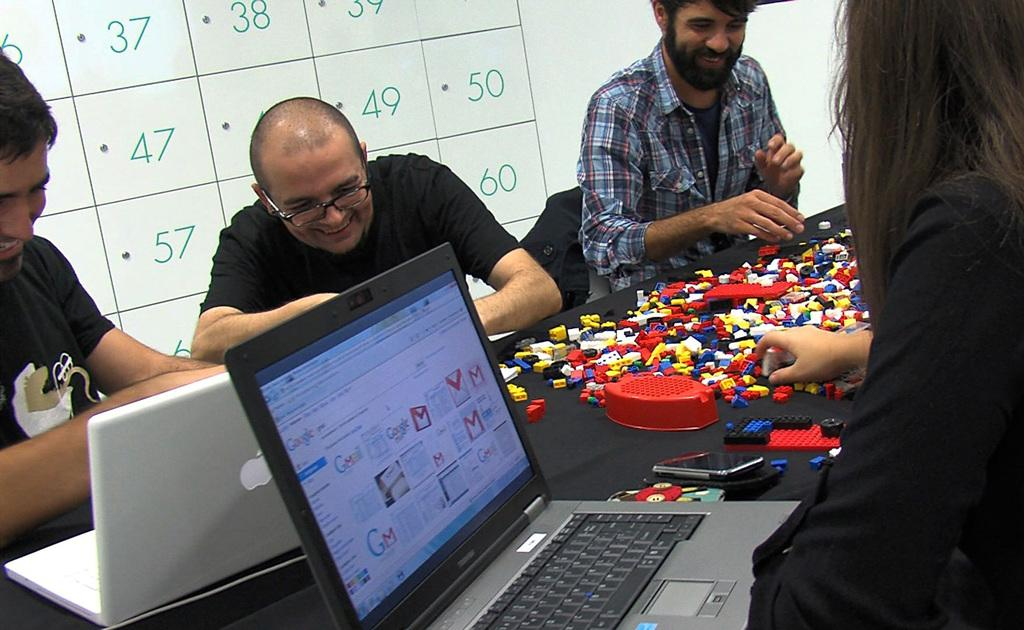Provide a one-sentence caption for the provided image. Men playing with legos with a white board behind them with the number 50 on it. 